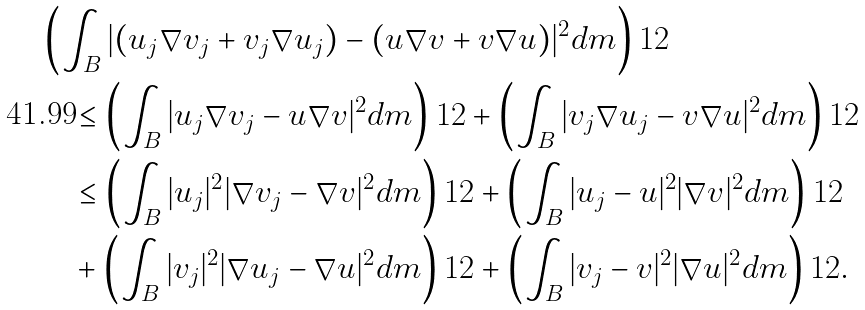Convert formula to latex. <formula><loc_0><loc_0><loc_500><loc_500>& \left ( \int _ { B } | ( u _ { j } \nabla v _ { j } + v _ { j } \nabla u _ { j } ) - ( u \nabla v + v \nabla u ) | ^ { 2 } d m \right ) ^ { } { 1 } 2 \\ & \quad \leq \left ( \int _ { B } | u _ { j } \nabla v _ { j } - u \nabla v | ^ { 2 } d m \right ) ^ { } { 1 } 2 + \left ( \int _ { B } | v _ { j } \nabla u _ { j } - v \nabla u | ^ { 2 } d m \right ) ^ { } { 1 } 2 \\ & \quad \leq \left ( \int _ { B } | u _ { j } | ^ { 2 } | \nabla v _ { j } - \nabla v | ^ { 2 } d m \right ) ^ { } { 1 } 2 + \left ( \int _ { B } | u _ { j } - u | ^ { 2 } | \nabla v | ^ { 2 } d m \right ) ^ { } { 1 } 2 \\ & \quad + \left ( \int _ { B } | v _ { j } | ^ { 2 } | \nabla u _ { j } - \nabla u | ^ { 2 } d m \right ) ^ { } { 1 } 2 + \left ( \int _ { B } | v _ { j } - v | ^ { 2 } | \nabla u | ^ { 2 } d m \right ) ^ { } { 1 } 2 . \\</formula> 